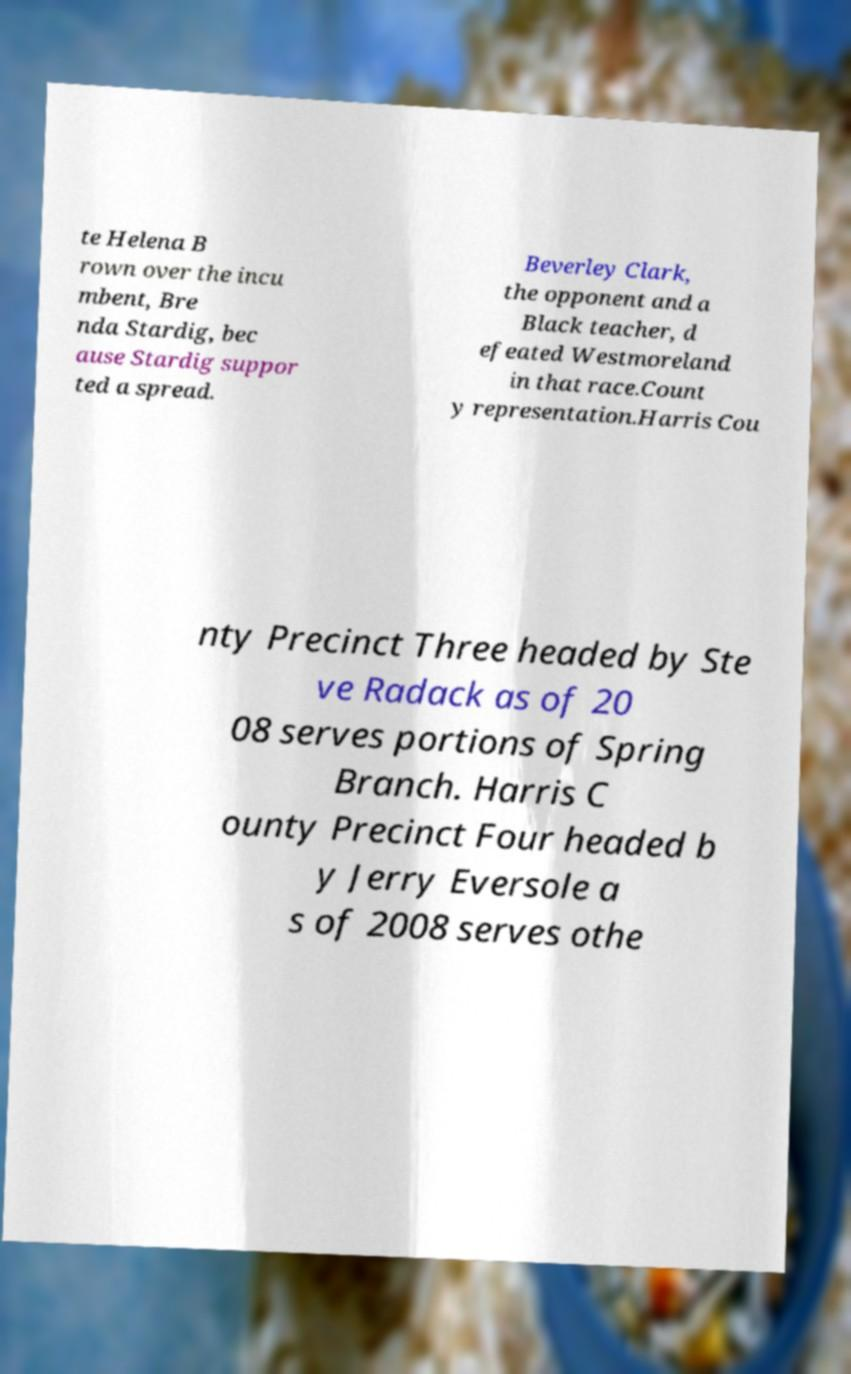Please identify and transcribe the text found in this image. te Helena B rown over the incu mbent, Bre nda Stardig, bec ause Stardig suppor ted a spread. Beverley Clark, the opponent and a Black teacher, d efeated Westmoreland in that race.Count y representation.Harris Cou nty Precinct Three headed by Ste ve Radack as of 20 08 serves portions of Spring Branch. Harris C ounty Precinct Four headed b y Jerry Eversole a s of 2008 serves othe 